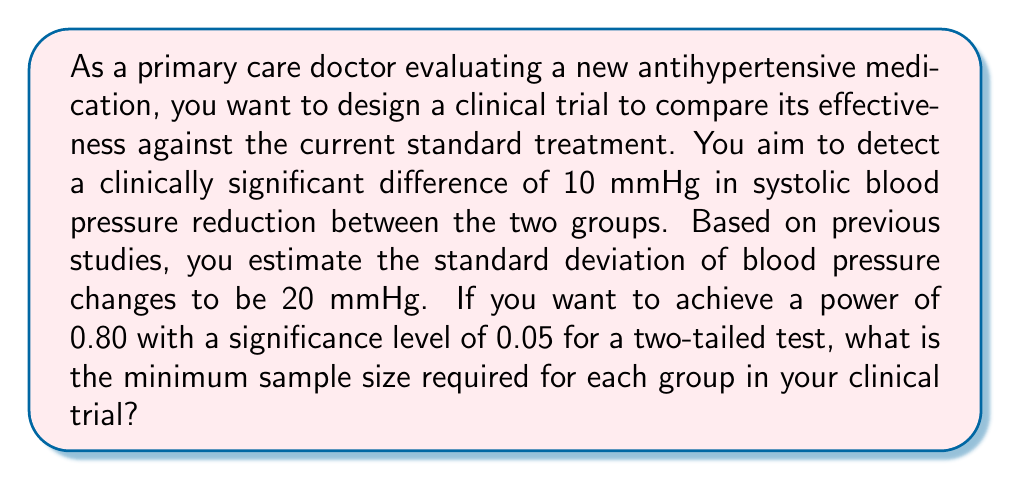Can you answer this question? To determine the optimal sample size for this clinical trial, we'll use power analysis. The steps are as follows:

1. Define the parameters:
   - Effect size (d) = Difference to detect / Standard deviation
   - $\alpha$ (significance level) = 0.05 (given)
   - $\beta$ (Type II error rate) = 1 - Power = 1 - 0.80 = 0.20
   - Two-tailed test

2. Calculate the effect size:
   $d = \frac{\text{Difference to detect}}{\text{Standard deviation}} = \frac{10}{20} = 0.5$

3. Determine the critical values:
   - $z_{1-\alpha/2} = z_{0.975} = 1.96$ (for $\alpha = 0.05$, two-tailed)
   - $z_{1-\beta} = z_{0.80} = 0.84$ (for power = 0.80)

4. Use the formula for sample size calculation:
   $$n = 2 \left(\frac{z_{1-\alpha/2} + z_{1-\beta}}{d}\right)^2 + \frac{1}{2}z_{1-\alpha/2}^2$$

5. Substitute the values:
   $$n = 2 \left(\frac{1.96 + 0.84}{0.5}\right)^2 + \frac{1}{2}(1.96)^2$$

6. Calculate:
   $$n = 2(5.6)^2 + 1.92 = 62.72 + 1.92 = 64.64$$

7. Round up to the nearest whole number:
   $n \approx 65$

Therefore, the minimum sample size required for each group in the clinical trial is 65 participants.
Answer: 65 participants per group 